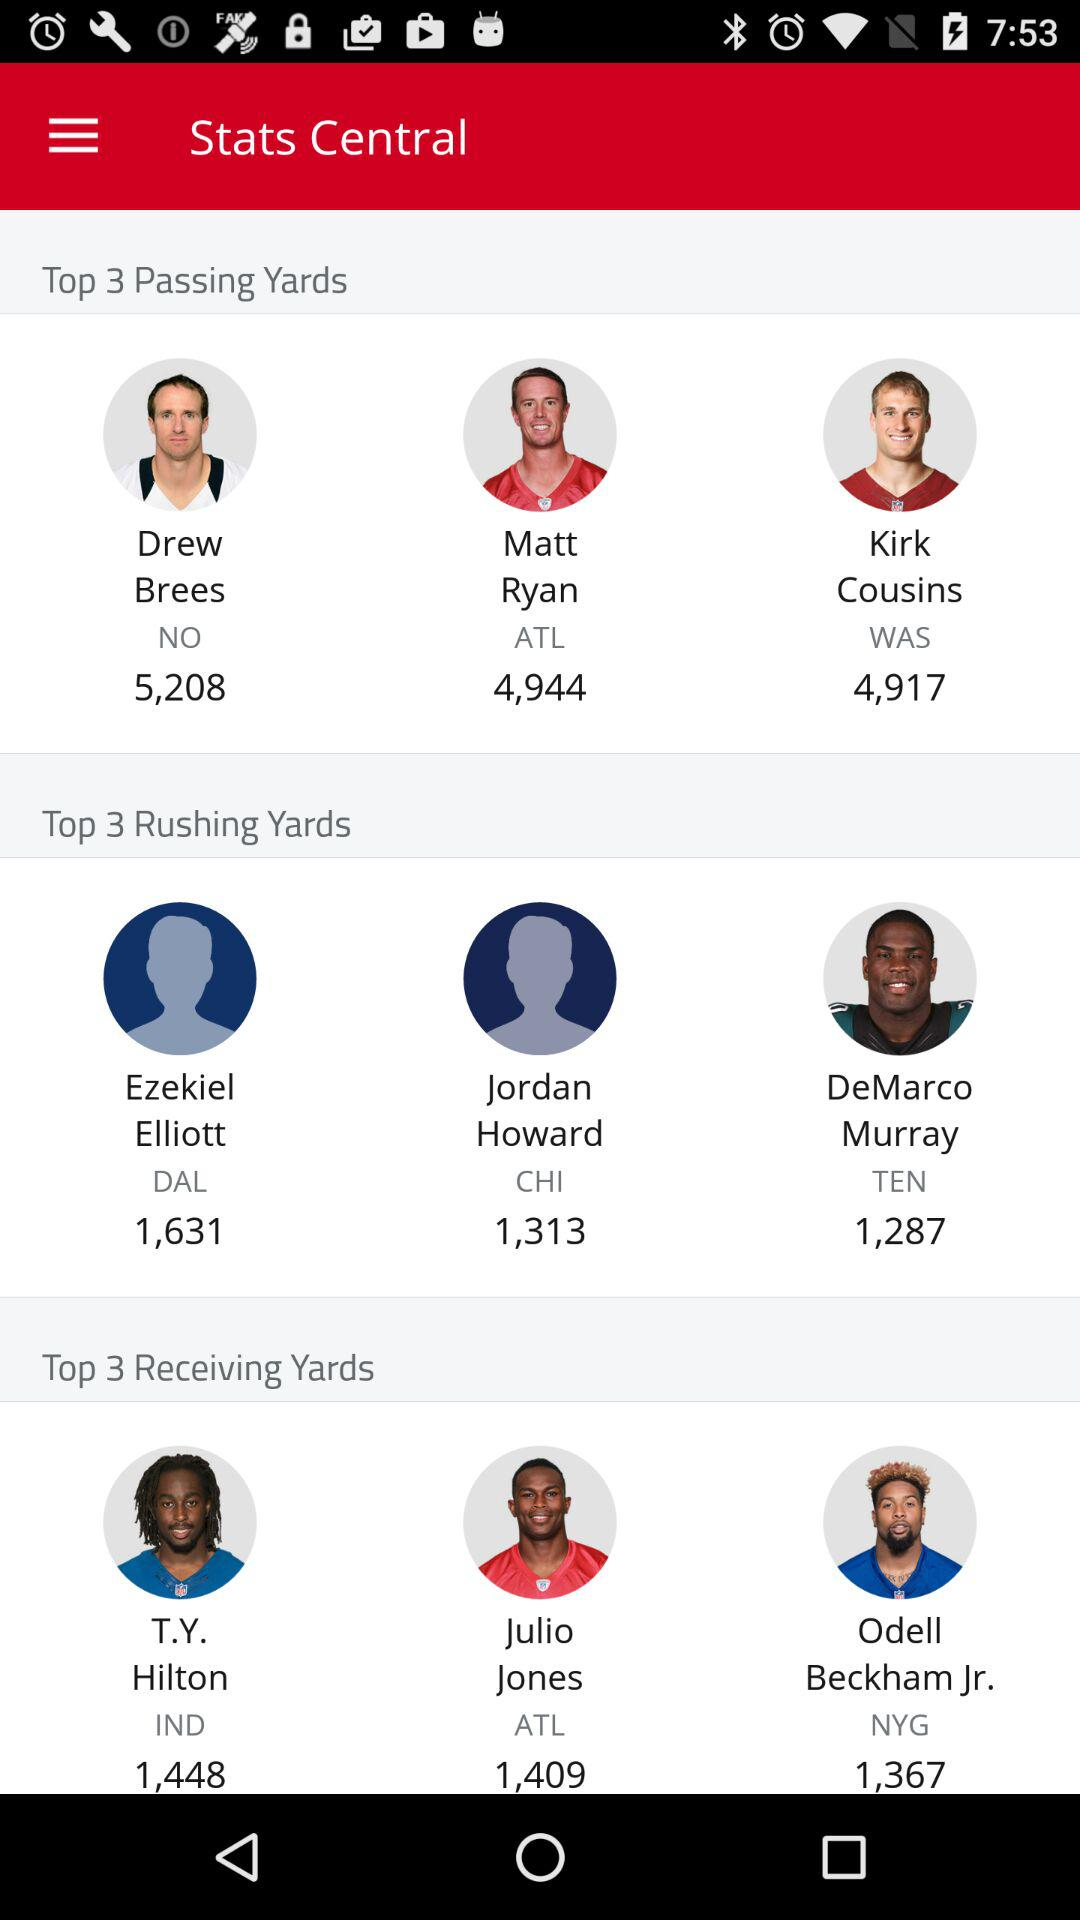How many more passing yards does Drew Brees have than Matt Ryan?
Answer the question using a single word or phrase. 264 